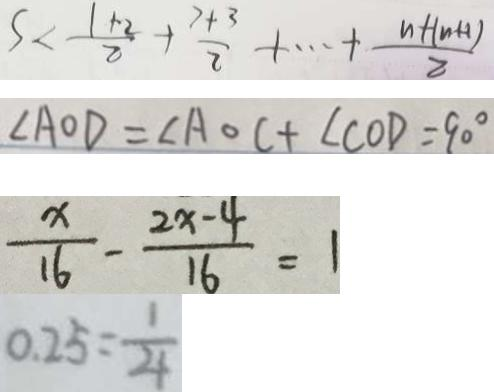Convert formula to latex. <formula><loc_0><loc_0><loc_500><loc_500>S < \frac { 1 + 2 } { 2 } + \frac { 7 + 3 } { 2 } + \cdots + \frac { n + ( n + 1 ) } { 2 } 
 \angle A O D = \angle A O C + \angle C O D = 9 0 ^ { \circ } 
 \frac { x } { 1 6 } - \frac { 2 x - 4 } { 1 6 } = 1 
 0 . 2 5 = \frac { 1 } { 4 }</formula> 